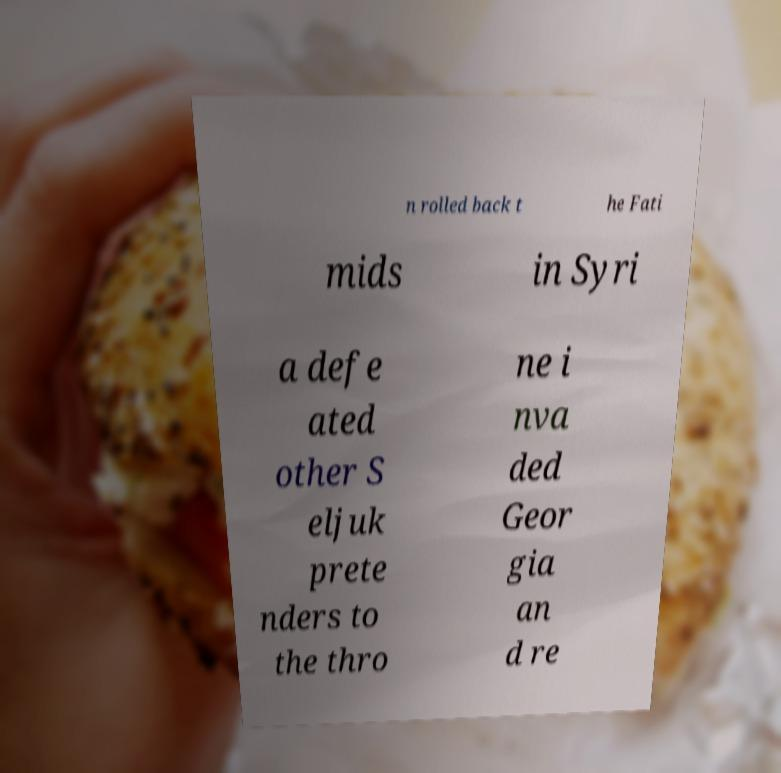I need the written content from this picture converted into text. Can you do that? n rolled back t he Fati mids in Syri a defe ated other S eljuk prete nders to the thro ne i nva ded Geor gia an d re 